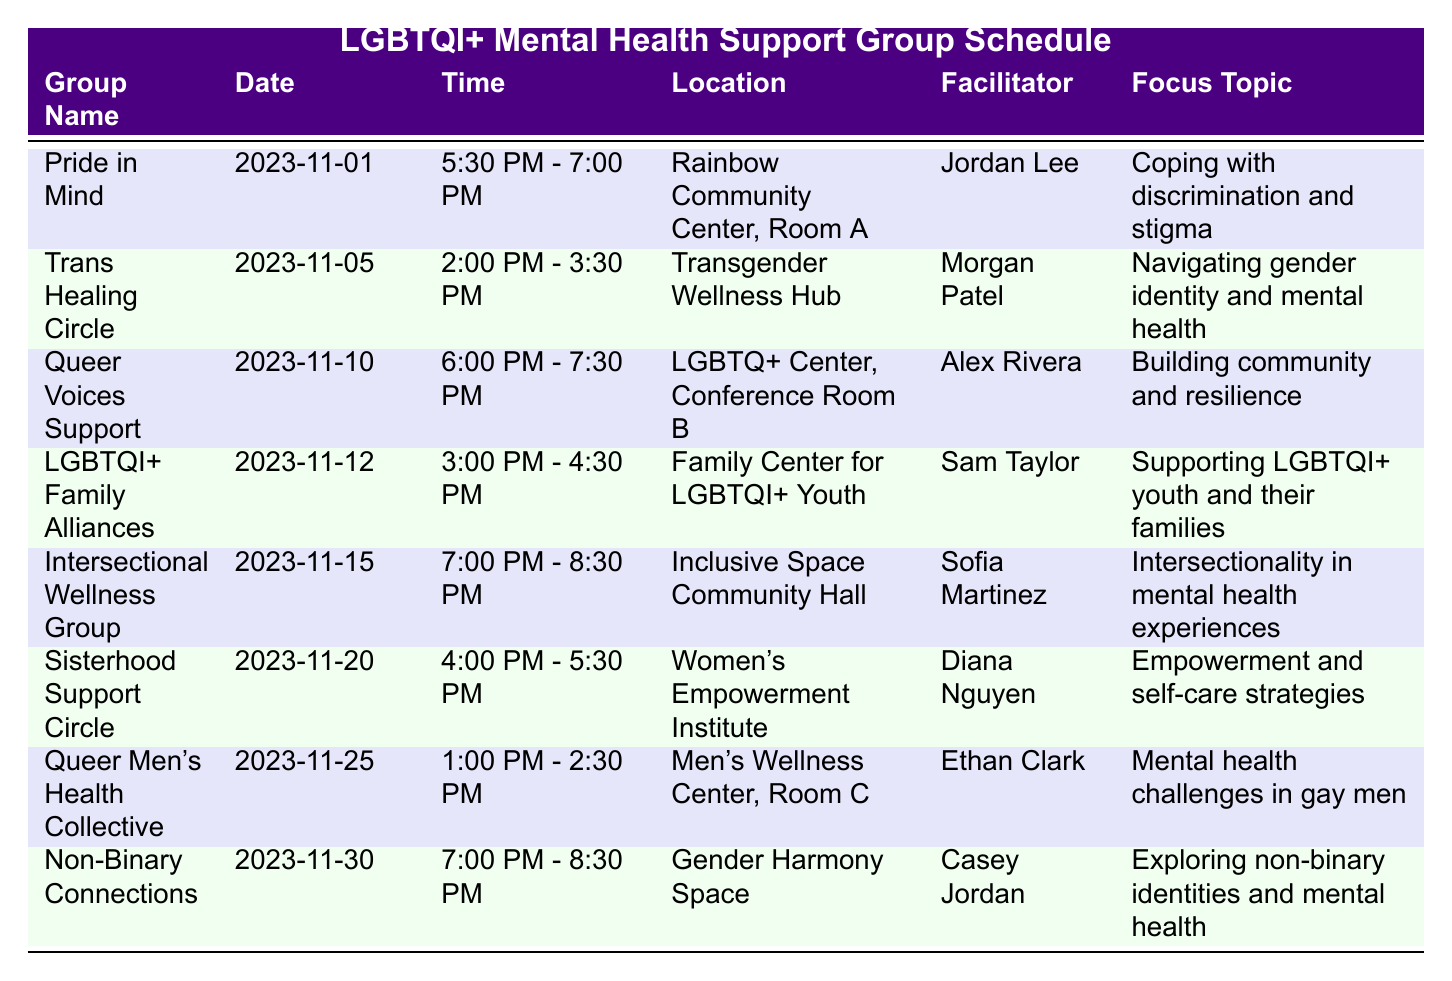What is the date of the "Pride in Mind" meeting? The table lists the meetings under the "Date" column. For "Pride in Mind," the corresponding date is provided directly in the table.
Answer: November 1, 2023 Who is the facilitator for the "Queer Voices Support" group? By reviewing the row for "Queer Voices Support" in the table, the facilitator's name is listed under the "Facilitator" column.
Answer: Alex Rivera What time does the "Intersectional Wellness Group" meet? The meeting time can be found in the row corresponding to "Intersectional Wellness Group" in the table under "Time."
Answer: 7:00 PM - 8:30 PM Is the "LGBTQI+ Family Alliances" meeting located at the "Family Center for LGBTQI+ Youth"? By checking the location listed under the "LGBTQI+ Family Alliances" row, we can verify if it matches the one mentioned. It does match, confirming the location.
Answer: Yes How many meetings are scheduled for November 2023? To find the total number of meetings, we can count each row of the table since each represents a separate meeting for that month. There are 8 rows in the table.
Answer: 8 Which group focuses on "Supporting LGBTQI+ youth and their families"? The table can be scanned for the focus topic "Supporting LGBTQI+ youth and their families" to find the corresponding group name. This is explicitly stated in the row for "LGBTQI+ Family Alliances."
Answer: LGBTQI+ Family Alliances What is the focus topic for the "Non-Binary Connections" group? The focus topic can be located in the row for "Non-Binary Connections" under the "Focus Topic" column.
Answer: Exploring non-binary identities and mental health Which meeting has the latest time slot in November? By checking the "Time" column of each meeting, we look for the latest ending time. The "Non-Binary Connections" group meetings from 7:00 PM to 8:30 PM represent the latest time.
Answer: Non-Binary Connections How many meetings occur in the second half of November? To determine this, we analyze the meeting dates in the table. The second half includes meetings on the 15th, 20th, and 25th, totaling three meetings.
Answer: 3 